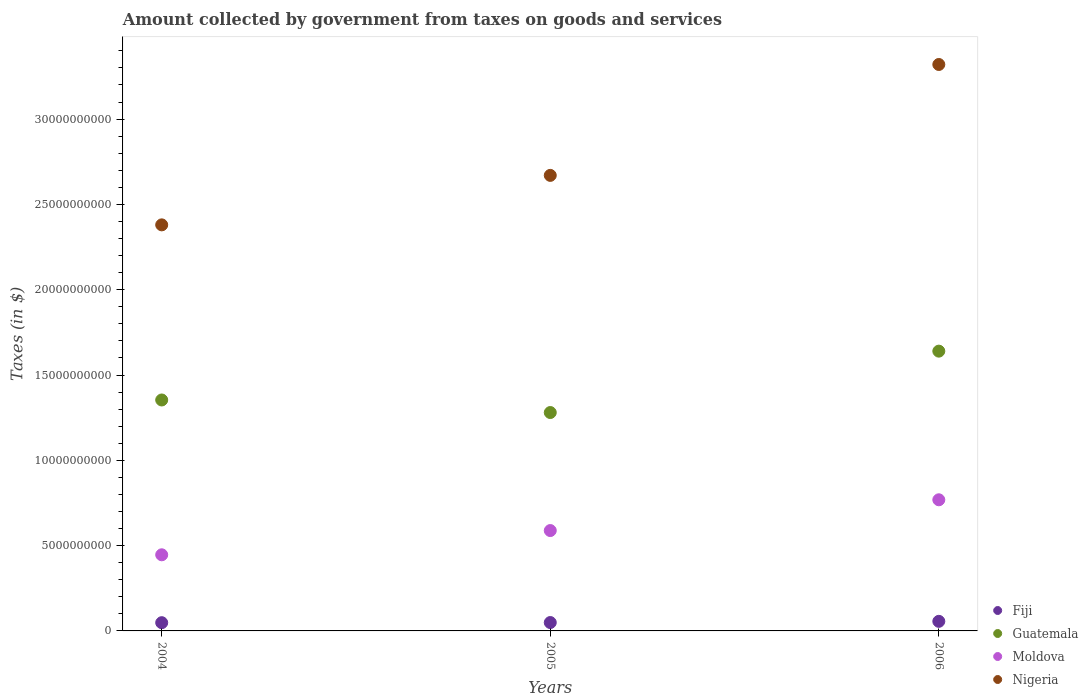Is the number of dotlines equal to the number of legend labels?
Provide a succinct answer. Yes. What is the amount collected by government from taxes on goods and services in Moldova in 2005?
Provide a succinct answer. 5.88e+09. Across all years, what is the maximum amount collected by government from taxes on goods and services in Guatemala?
Your answer should be very brief. 1.64e+1. Across all years, what is the minimum amount collected by government from taxes on goods and services in Fiji?
Ensure brevity in your answer.  4.83e+08. In which year was the amount collected by government from taxes on goods and services in Nigeria minimum?
Give a very brief answer. 2004. What is the total amount collected by government from taxes on goods and services in Guatemala in the graph?
Provide a succinct answer. 4.27e+1. What is the difference between the amount collected by government from taxes on goods and services in Moldova in 2004 and that in 2006?
Provide a succinct answer. -3.22e+09. What is the difference between the amount collected by government from taxes on goods and services in Moldova in 2006 and the amount collected by government from taxes on goods and services in Guatemala in 2004?
Provide a succinct answer. -5.85e+09. What is the average amount collected by government from taxes on goods and services in Guatemala per year?
Provide a short and direct response. 1.42e+1. In the year 2004, what is the difference between the amount collected by government from taxes on goods and services in Fiji and amount collected by government from taxes on goods and services in Moldova?
Give a very brief answer. -3.98e+09. In how many years, is the amount collected by government from taxes on goods and services in Guatemala greater than 31000000000 $?
Offer a terse response. 0. What is the ratio of the amount collected by government from taxes on goods and services in Fiji in 2004 to that in 2005?
Provide a succinct answer. 0.98. Is the difference between the amount collected by government from taxes on goods and services in Fiji in 2005 and 2006 greater than the difference between the amount collected by government from taxes on goods and services in Moldova in 2005 and 2006?
Keep it short and to the point. Yes. What is the difference between the highest and the second highest amount collected by government from taxes on goods and services in Nigeria?
Offer a terse response. 6.50e+09. What is the difference between the highest and the lowest amount collected by government from taxes on goods and services in Nigeria?
Provide a succinct answer. 9.40e+09. Is it the case that in every year, the sum of the amount collected by government from taxes on goods and services in Fiji and amount collected by government from taxes on goods and services in Guatemala  is greater than the amount collected by government from taxes on goods and services in Nigeria?
Provide a succinct answer. No. How many years are there in the graph?
Your answer should be compact. 3. What is the difference between two consecutive major ticks on the Y-axis?
Your answer should be very brief. 5.00e+09. Does the graph contain grids?
Your response must be concise. No. What is the title of the graph?
Give a very brief answer. Amount collected by government from taxes on goods and services. What is the label or title of the X-axis?
Provide a short and direct response. Years. What is the label or title of the Y-axis?
Your answer should be very brief. Taxes (in $). What is the Taxes (in $) in Fiji in 2004?
Provide a succinct answer. 4.83e+08. What is the Taxes (in $) of Guatemala in 2004?
Keep it short and to the point. 1.35e+1. What is the Taxes (in $) of Moldova in 2004?
Your answer should be very brief. 4.46e+09. What is the Taxes (in $) in Nigeria in 2004?
Provide a succinct answer. 2.38e+1. What is the Taxes (in $) in Fiji in 2005?
Your answer should be very brief. 4.91e+08. What is the Taxes (in $) of Guatemala in 2005?
Ensure brevity in your answer.  1.28e+1. What is the Taxes (in $) in Moldova in 2005?
Keep it short and to the point. 5.88e+09. What is the Taxes (in $) of Nigeria in 2005?
Offer a very short reply. 2.67e+1. What is the Taxes (in $) of Fiji in 2006?
Provide a short and direct response. 5.62e+08. What is the Taxes (in $) of Guatemala in 2006?
Ensure brevity in your answer.  1.64e+1. What is the Taxes (in $) of Moldova in 2006?
Give a very brief answer. 7.69e+09. What is the Taxes (in $) in Nigeria in 2006?
Your answer should be very brief. 3.32e+1. Across all years, what is the maximum Taxes (in $) in Fiji?
Keep it short and to the point. 5.62e+08. Across all years, what is the maximum Taxes (in $) in Guatemala?
Provide a succinct answer. 1.64e+1. Across all years, what is the maximum Taxes (in $) of Moldova?
Offer a very short reply. 7.69e+09. Across all years, what is the maximum Taxes (in $) of Nigeria?
Offer a terse response. 3.32e+1. Across all years, what is the minimum Taxes (in $) of Fiji?
Offer a very short reply. 4.83e+08. Across all years, what is the minimum Taxes (in $) in Guatemala?
Your response must be concise. 1.28e+1. Across all years, what is the minimum Taxes (in $) in Moldova?
Ensure brevity in your answer.  4.46e+09. Across all years, what is the minimum Taxes (in $) of Nigeria?
Make the answer very short. 2.38e+1. What is the total Taxes (in $) of Fiji in the graph?
Your response must be concise. 1.54e+09. What is the total Taxes (in $) in Guatemala in the graph?
Your answer should be compact. 4.27e+1. What is the total Taxes (in $) of Moldova in the graph?
Offer a terse response. 1.80e+1. What is the total Taxes (in $) in Nigeria in the graph?
Make the answer very short. 8.37e+1. What is the difference between the Taxes (in $) in Fiji in 2004 and that in 2005?
Keep it short and to the point. -8.84e+06. What is the difference between the Taxes (in $) of Guatemala in 2004 and that in 2005?
Keep it short and to the point. 7.36e+08. What is the difference between the Taxes (in $) of Moldova in 2004 and that in 2005?
Make the answer very short. -1.42e+09. What is the difference between the Taxes (in $) of Nigeria in 2004 and that in 2005?
Offer a terse response. -2.90e+09. What is the difference between the Taxes (in $) in Fiji in 2004 and that in 2006?
Keep it short and to the point. -7.89e+07. What is the difference between the Taxes (in $) in Guatemala in 2004 and that in 2006?
Provide a short and direct response. -2.86e+09. What is the difference between the Taxes (in $) of Moldova in 2004 and that in 2006?
Offer a very short reply. -3.22e+09. What is the difference between the Taxes (in $) in Nigeria in 2004 and that in 2006?
Your answer should be compact. -9.40e+09. What is the difference between the Taxes (in $) in Fiji in 2005 and that in 2006?
Give a very brief answer. -7.00e+07. What is the difference between the Taxes (in $) in Guatemala in 2005 and that in 2006?
Make the answer very short. -3.60e+09. What is the difference between the Taxes (in $) of Moldova in 2005 and that in 2006?
Keep it short and to the point. -1.80e+09. What is the difference between the Taxes (in $) of Nigeria in 2005 and that in 2006?
Give a very brief answer. -6.50e+09. What is the difference between the Taxes (in $) of Fiji in 2004 and the Taxes (in $) of Guatemala in 2005?
Offer a very short reply. -1.23e+1. What is the difference between the Taxes (in $) in Fiji in 2004 and the Taxes (in $) in Moldova in 2005?
Offer a very short reply. -5.40e+09. What is the difference between the Taxes (in $) of Fiji in 2004 and the Taxes (in $) of Nigeria in 2005?
Make the answer very short. -2.62e+1. What is the difference between the Taxes (in $) in Guatemala in 2004 and the Taxes (in $) in Moldova in 2005?
Keep it short and to the point. 7.65e+09. What is the difference between the Taxes (in $) of Guatemala in 2004 and the Taxes (in $) of Nigeria in 2005?
Your response must be concise. -1.32e+1. What is the difference between the Taxes (in $) in Moldova in 2004 and the Taxes (in $) in Nigeria in 2005?
Your response must be concise. -2.22e+1. What is the difference between the Taxes (in $) in Fiji in 2004 and the Taxes (in $) in Guatemala in 2006?
Your answer should be very brief. -1.59e+1. What is the difference between the Taxes (in $) of Fiji in 2004 and the Taxes (in $) of Moldova in 2006?
Provide a short and direct response. -7.20e+09. What is the difference between the Taxes (in $) in Fiji in 2004 and the Taxes (in $) in Nigeria in 2006?
Offer a terse response. -3.27e+1. What is the difference between the Taxes (in $) of Guatemala in 2004 and the Taxes (in $) of Moldova in 2006?
Offer a very short reply. 5.85e+09. What is the difference between the Taxes (in $) in Guatemala in 2004 and the Taxes (in $) in Nigeria in 2006?
Your response must be concise. -1.97e+1. What is the difference between the Taxes (in $) in Moldova in 2004 and the Taxes (in $) in Nigeria in 2006?
Keep it short and to the point. -2.87e+1. What is the difference between the Taxes (in $) in Fiji in 2005 and the Taxes (in $) in Guatemala in 2006?
Your answer should be compact. -1.59e+1. What is the difference between the Taxes (in $) of Fiji in 2005 and the Taxes (in $) of Moldova in 2006?
Keep it short and to the point. -7.19e+09. What is the difference between the Taxes (in $) of Fiji in 2005 and the Taxes (in $) of Nigeria in 2006?
Keep it short and to the point. -3.27e+1. What is the difference between the Taxes (in $) of Guatemala in 2005 and the Taxes (in $) of Moldova in 2006?
Make the answer very short. 5.11e+09. What is the difference between the Taxes (in $) of Guatemala in 2005 and the Taxes (in $) of Nigeria in 2006?
Give a very brief answer. -2.04e+1. What is the difference between the Taxes (in $) of Moldova in 2005 and the Taxes (in $) of Nigeria in 2006?
Ensure brevity in your answer.  -2.73e+1. What is the average Taxes (in $) of Fiji per year?
Give a very brief answer. 5.12e+08. What is the average Taxes (in $) in Guatemala per year?
Offer a terse response. 1.42e+1. What is the average Taxes (in $) in Moldova per year?
Your answer should be very brief. 6.01e+09. What is the average Taxes (in $) of Nigeria per year?
Make the answer very short. 2.79e+1. In the year 2004, what is the difference between the Taxes (in $) in Fiji and Taxes (in $) in Guatemala?
Give a very brief answer. -1.31e+1. In the year 2004, what is the difference between the Taxes (in $) of Fiji and Taxes (in $) of Moldova?
Your answer should be very brief. -3.98e+09. In the year 2004, what is the difference between the Taxes (in $) in Fiji and Taxes (in $) in Nigeria?
Provide a succinct answer. -2.33e+1. In the year 2004, what is the difference between the Taxes (in $) in Guatemala and Taxes (in $) in Moldova?
Your answer should be compact. 9.07e+09. In the year 2004, what is the difference between the Taxes (in $) in Guatemala and Taxes (in $) in Nigeria?
Provide a succinct answer. -1.03e+1. In the year 2004, what is the difference between the Taxes (in $) in Moldova and Taxes (in $) in Nigeria?
Your answer should be compact. -1.93e+1. In the year 2005, what is the difference between the Taxes (in $) in Fiji and Taxes (in $) in Guatemala?
Ensure brevity in your answer.  -1.23e+1. In the year 2005, what is the difference between the Taxes (in $) of Fiji and Taxes (in $) of Moldova?
Give a very brief answer. -5.39e+09. In the year 2005, what is the difference between the Taxes (in $) of Fiji and Taxes (in $) of Nigeria?
Your answer should be compact. -2.62e+1. In the year 2005, what is the difference between the Taxes (in $) of Guatemala and Taxes (in $) of Moldova?
Your answer should be compact. 6.92e+09. In the year 2005, what is the difference between the Taxes (in $) of Guatemala and Taxes (in $) of Nigeria?
Your answer should be very brief. -1.39e+1. In the year 2005, what is the difference between the Taxes (in $) in Moldova and Taxes (in $) in Nigeria?
Make the answer very short. -2.08e+1. In the year 2006, what is the difference between the Taxes (in $) of Fiji and Taxes (in $) of Guatemala?
Offer a very short reply. -1.58e+1. In the year 2006, what is the difference between the Taxes (in $) of Fiji and Taxes (in $) of Moldova?
Your answer should be very brief. -7.12e+09. In the year 2006, what is the difference between the Taxes (in $) in Fiji and Taxes (in $) in Nigeria?
Your answer should be compact. -3.26e+1. In the year 2006, what is the difference between the Taxes (in $) of Guatemala and Taxes (in $) of Moldova?
Your answer should be compact. 8.71e+09. In the year 2006, what is the difference between the Taxes (in $) in Guatemala and Taxes (in $) in Nigeria?
Offer a terse response. -1.68e+1. In the year 2006, what is the difference between the Taxes (in $) in Moldova and Taxes (in $) in Nigeria?
Your answer should be very brief. -2.55e+1. What is the ratio of the Taxes (in $) of Fiji in 2004 to that in 2005?
Offer a very short reply. 0.98. What is the ratio of the Taxes (in $) in Guatemala in 2004 to that in 2005?
Your response must be concise. 1.06. What is the ratio of the Taxes (in $) of Moldova in 2004 to that in 2005?
Offer a terse response. 0.76. What is the ratio of the Taxes (in $) of Nigeria in 2004 to that in 2005?
Your response must be concise. 0.89. What is the ratio of the Taxes (in $) in Fiji in 2004 to that in 2006?
Ensure brevity in your answer.  0.86. What is the ratio of the Taxes (in $) in Guatemala in 2004 to that in 2006?
Your response must be concise. 0.83. What is the ratio of the Taxes (in $) in Moldova in 2004 to that in 2006?
Offer a terse response. 0.58. What is the ratio of the Taxes (in $) of Nigeria in 2004 to that in 2006?
Your response must be concise. 0.72. What is the ratio of the Taxes (in $) of Fiji in 2005 to that in 2006?
Provide a succinct answer. 0.88. What is the ratio of the Taxes (in $) in Guatemala in 2005 to that in 2006?
Offer a very short reply. 0.78. What is the ratio of the Taxes (in $) in Moldova in 2005 to that in 2006?
Your response must be concise. 0.77. What is the ratio of the Taxes (in $) in Nigeria in 2005 to that in 2006?
Offer a very short reply. 0.8. What is the difference between the highest and the second highest Taxes (in $) of Fiji?
Provide a succinct answer. 7.00e+07. What is the difference between the highest and the second highest Taxes (in $) of Guatemala?
Keep it short and to the point. 2.86e+09. What is the difference between the highest and the second highest Taxes (in $) in Moldova?
Keep it short and to the point. 1.80e+09. What is the difference between the highest and the second highest Taxes (in $) in Nigeria?
Provide a succinct answer. 6.50e+09. What is the difference between the highest and the lowest Taxes (in $) in Fiji?
Your answer should be very brief. 7.89e+07. What is the difference between the highest and the lowest Taxes (in $) of Guatemala?
Offer a terse response. 3.60e+09. What is the difference between the highest and the lowest Taxes (in $) in Moldova?
Your answer should be compact. 3.22e+09. What is the difference between the highest and the lowest Taxes (in $) of Nigeria?
Offer a very short reply. 9.40e+09. 